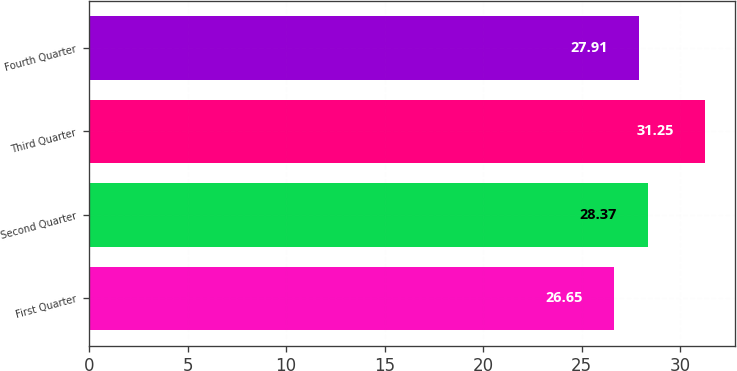<chart> <loc_0><loc_0><loc_500><loc_500><bar_chart><fcel>First Quarter<fcel>Second Quarter<fcel>Third Quarter<fcel>Fourth Quarter<nl><fcel>26.65<fcel>28.37<fcel>31.25<fcel>27.91<nl></chart> 